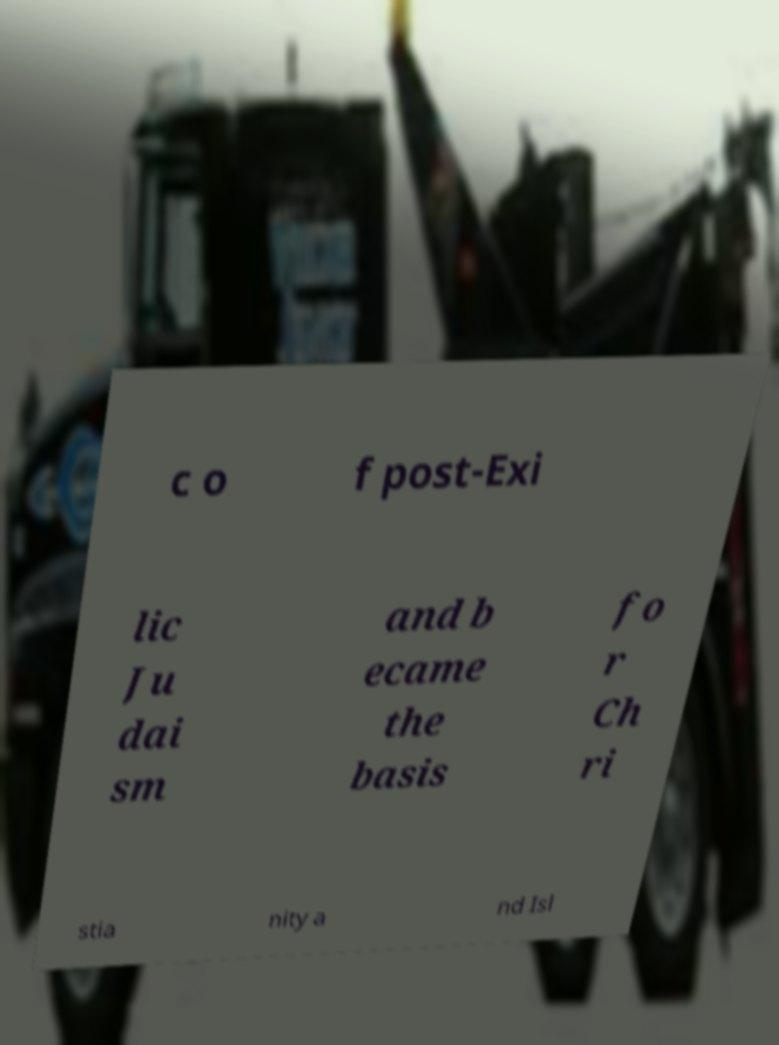Can you accurately transcribe the text from the provided image for me? c o f post-Exi lic Ju dai sm and b ecame the basis fo r Ch ri stia nity a nd Isl 